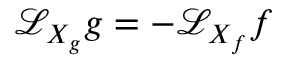Convert formula to latex. <formula><loc_0><loc_0><loc_500><loc_500>\mathcal { L } _ { X _ { g } } g = \mathcal { - L } _ { X _ { f } } f</formula> 